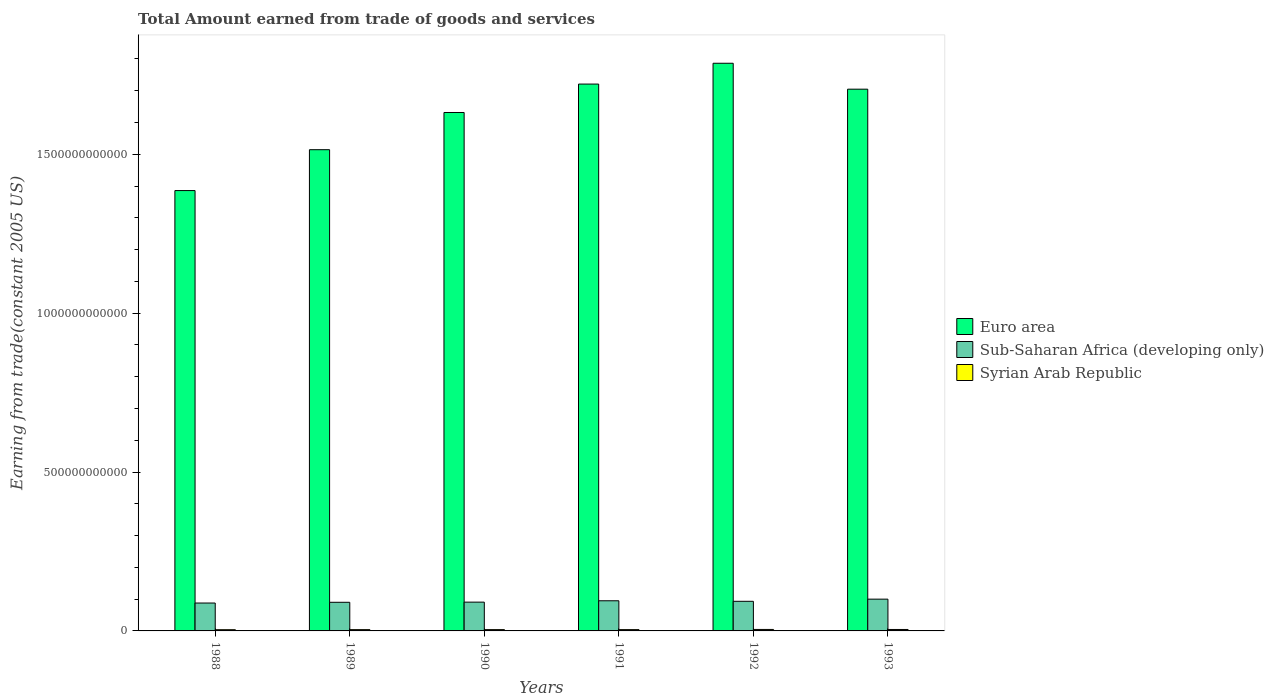How many different coloured bars are there?
Ensure brevity in your answer.  3. How many groups of bars are there?
Make the answer very short. 6. Are the number of bars per tick equal to the number of legend labels?
Make the answer very short. Yes. Are the number of bars on each tick of the X-axis equal?
Offer a terse response. Yes. How many bars are there on the 3rd tick from the left?
Offer a very short reply. 3. What is the label of the 5th group of bars from the left?
Your response must be concise. 1992. What is the total amount earned by trading goods and services in Euro area in 1989?
Make the answer very short. 1.51e+12. Across all years, what is the maximum total amount earned by trading goods and services in Sub-Saharan Africa (developing only)?
Make the answer very short. 1.00e+11. Across all years, what is the minimum total amount earned by trading goods and services in Euro area?
Your answer should be very brief. 1.39e+12. In which year was the total amount earned by trading goods and services in Sub-Saharan Africa (developing only) maximum?
Give a very brief answer. 1993. In which year was the total amount earned by trading goods and services in Syrian Arab Republic minimum?
Make the answer very short. 1988. What is the total total amount earned by trading goods and services in Sub-Saharan Africa (developing only) in the graph?
Your answer should be very brief. 5.57e+11. What is the difference between the total amount earned by trading goods and services in Syrian Arab Republic in 1988 and that in 1992?
Ensure brevity in your answer.  -7.70e+08. What is the difference between the total amount earned by trading goods and services in Syrian Arab Republic in 1988 and the total amount earned by trading goods and services in Euro area in 1990?
Offer a terse response. -1.63e+12. What is the average total amount earned by trading goods and services in Euro area per year?
Your response must be concise. 1.62e+12. In the year 1989, what is the difference between the total amount earned by trading goods and services in Euro area and total amount earned by trading goods and services in Sub-Saharan Africa (developing only)?
Make the answer very short. 1.42e+12. In how many years, is the total amount earned by trading goods and services in Euro area greater than 1000000000000 US$?
Offer a very short reply. 6. What is the ratio of the total amount earned by trading goods and services in Syrian Arab Republic in 1991 to that in 1992?
Offer a terse response. 0.89. Is the total amount earned by trading goods and services in Syrian Arab Republic in 1992 less than that in 1993?
Offer a terse response. No. What is the difference between the highest and the second highest total amount earned by trading goods and services in Sub-Saharan Africa (developing only)?
Your answer should be compact. 5.12e+09. What is the difference between the highest and the lowest total amount earned by trading goods and services in Sub-Saharan Africa (developing only)?
Offer a terse response. 1.22e+1. What does the 1st bar from the left in 1989 represents?
Provide a short and direct response. Euro area. What does the 2nd bar from the right in 1988 represents?
Give a very brief answer. Sub-Saharan Africa (developing only). Are all the bars in the graph horizontal?
Make the answer very short. No. How many years are there in the graph?
Offer a terse response. 6. What is the difference between two consecutive major ticks on the Y-axis?
Provide a succinct answer. 5.00e+11. Does the graph contain grids?
Your answer should be very brief. No. How many legend labels are there?
Provide a short and direct response. 3. How are the legend labels stacked?
Keep it short and to the point. Vertical. What is the title of the graph?
Offer a very short reply. Total Amount earned from trade of goods and services. Does "Cayman Islands" appear as one of the legend labels in the graph?
Give a very brief answer. No. What is the label or title of the Y-axis?
Make the answer very short. Earning from trade(constant 2005 US). What is the Earning from trade(constant 2005 US) of Euro area in 1988?
Provide a short and direct response. 1.39e+12. What is the Earning from trade(constant 2005 US) in Sub-Saharan Africa (developing only) in 1988?
Give a very brief answer. 8.78e+1. What is the Earning from trade(constant 2005 US) in Syrian Arab Republic in 1988?
Provide a succinct answer. 3.87e+09. What is the Earning from trade(constant 2005 US) in Euro area in 1989?
Offer a terse response. 1.51e+12. What is the Earning from trade(constant 2005 US) in Sub-Saharan Africa (developing only) in 1989?
Keep it short and to the point. 9.01e+1. What is the Earning from trade(constant 2005 US) of Syrian Arab Republic in 1989?
Offer a very short reply. 4.07e+09. What is the Earning from trade(constant 2005 US) of Euro area in 1990?
Your response must be concise. 1.63e+12. What is the Earning from trade(constant 2005 US) in Sub-Saharan Africa (developing only) in 1990?
Give a very brief answer. 9.06e+1. What is the Earning from trade(constant 2005 US) in Syrian Arab Republic in 1990?
Provide a short and direct response. 4.11e+09. What is the Earning from trade(constant 2005 US) of Euro area in 1991?
Make the answer very short. 1.72e+12. What is the Earning from trade(constant 2005 US) in Sub-Saharan Africa (developing only) in 1991?
Give a very brief answer. 9.49e+1. What is the Earning from trade(constant 2005 US) of Syrian Arab Republic in 1991?
Offer a terse response. 4.11e+09. What is the Earning from trade(constant 2005 US) in Euro area in 1992?
Provide a short and direct response. 1.79e+12. What is the Earning from trade(constant 2005 US) in Sub-Saharan Africa (developing only) in 1992?
Offer a very short reply. 9.32e+1. What is the Earning from trade(constant 2005 US) of Syrian Arab Republic in 1992?
Ensure brevity in your answer.  4.64e+09. What is the Earning from trade(constant 2005 US) in Euro area in 1993?
Offer a very short reply. 1.70e+12. What is the Earning from trade(constant 2005 US) in Sub-Saharan Africa (developing only) in 1993?
Provide a succinct answer. 1.00e+11. What is the Earning from trade(constant 2005 US) in Syrian Arab Republic in 1993?
Keep it short and to the point. 4.53e+09. Across all years, what is the maximum Earning from trade(constant 2005 US) in Euro area?
Ensure brevity in your answer.  1.79e+12. Across all years, what is the maximum Earning from trade(constant 2005 US) of Sub-Saharan Africa (developing only)?
Provide a succinct answer. 1.00e+11. Across all years, what is the maximum Earning from trade(constant 2005 US) in Syrian Arab Republic?
Ensure brevity in your answer.  4.64e+09. Across all years, what is the minimum Earning from trade(constant 2005 US) of Euro area?
Keep it short and to the point. 1.39e+12. Across all years, what is the minimum Earning from trade(constant 2005 US) in Sub-Saharan Africa (developing only)?
Your answer should be compact. 8.78e+1. Across all years, what is the minimum Earning from trade(constant 2005 US) in Syrian Arab Republic?
Keep it short and to the point. 3.87e+09. What is the total Earning from trade(constant 2005 US) of Euro area in the graph?
Ensure brevity in your answer.  9.74e+12. What is the total Earning from trade(constant 2005 US) in Sub-Saharan Africa (developing only) in the graph?
Keep it short and to the point. 5.57e+11. What is the total Earning from trade(constant 2005 US) of Syrian Arab Republic in the graph?
Your response must be concise. 2.53e+1. What is the difference between the Earning from trade(constant 2005 US) in Euro area in 1988 and that in 1989?
Provide a succinct answer. -1.29e+11. What is the difference between the Earning from trade(constant 2005 US) of Sub-Saharan Africa (developing only) in 1988 and that in 1989?
Make the answer very short. -2.34e+09. What is the difference between the Earning from trade(constant 2005 US) in Syrian Arab Republic in 1988 and that in 1989?
Offer a terse response. -2.02e+08. What is the difference between the Earning from trade(constant 2005 US) in Euro area in 1988 and that in 1990?
Offer a very short reply. -2.46e+11. What is the difference between the Earning from trade(constant 2005 US) of Sub-Saharan Africa (developing only) in 1988 and that in 1990?
Give a very brief answer. -2.82e+09. What is the difference between the Earning from trade(constant 2005 US) in Syrian Arab Republic in 1988 and that in 1990?
Provide a succinct answer. -2.37e+08. What is the difference between the Earning from trade(constant 2005 US) of Euro area in 1988 and that in 1991?
Provide a succinct answer. -3.35e+11. What is the difference between the Earning from trade(constant 2005 US) in Sub-Saharan Africa (developing only) in 1988 and that in 1991?
Provide a short and direct response. -7.10e+09. What is the difference between the Earning from trade(constant 2005 US) in Syrian Arab Republic in 1988 and that in 1991?
Your response must be concise. -2.37e+08. What is the difference between the Earning from trade(constant 2005 US) in Euro area in 1988 and that in 1992?
Your response must be concise. -4.01e+11. What is the difference between the Earning from trade(constant 2005 US) of Sub-Saharan Africa (developing only) in 1988 and that in 1992?
Your answer should be very brief. -5.42e+09. What is the difference between the Earning from trade(constant 2005 US) in Syrian Arab Republic in 1988 and that in 1992?
Ensure brevity in your answer.  -7.70e+08. What is the difference between the Earning from trade(constant 2005 US) of Euro area in 1988 and that in 1993?
Offer a terse response. -3.19e+11. What is the difference between the Earning from trade(constant 2005 US) in Sub-Saharan Africa (developing only) in 1988 and that in 1993?
Provide a short and direct response. -1.22e+1. What is the difference between the Earning from trade(constant 2005 US) of Syrian Arab Republic in 1988 and that in 1993?
Ensure brevity in your answer.  -6.60e+08. What is the difference between the Earning from trade(constant 2005 US) of Euro area in 1989 and that in 1990?
Keep it short and to the point. -1.17e+11. What is the difference between the Earning from trade(constant 2005 US) in Sub-Saharan Africa (developing only) in 1989 and that in 1990?
Offer a very short reply. -4.75e+08. What is the difference between the Earning from trade(constant 2005 US) of Syrian Arab Republic in 1989 and that in 1990?
Your answer should be compact. -3.50e+07. What is the difference between the Earning from trade(constant 2005 US) in Euro area in 1989 and that in 1991?
Your answer should be compact. -2.07e+11. What is the difference between the Earning from trade(constant 2005 US) of Sub-Saharan Africa (developing only) in 1989 and that in 1991?
Offer a terse response. -4.76e+09. What is the difference between the Earning from trade(constant 2005 US) in Syrian Arab Republic in 1989 and that in 1991?
Your answer should be compact. -3.55e+07. What is the difference between the Earning from trade(constant 2005 US) in Euro area in 1989 and that in 1992?
Offer a terse response. -2.72e+11. What is the difference between the Earning from trade(constant 2005 US) in Sub-Saharan Africa (developing only) in 1989 and that in 1992?
Offer a terse response. -3.08e+09. What is the difference between the Earning from trade(constant 2005 US) of Syrian Arab Republic in 1989 and that in 1992?
Make the answer very short. -5.68e+08. What is the difference between the Earning from trade(constant 2005 US) in Euro area in 1989 and that in 1993?
Offer a terse response. -1.90e+11. What is the difference between the Earning from trade(constant 2005 US) in Sub-Saharan Africa (developing only) in 1989 and that in 1993?
Provide a succinct answer. -9.88e+09. What is the difference between the Earning from trade(constant 2005 US) of Syrian Arab Republic in 1989 and that in 1993?
Provide a short and direct response. -4.59e+08. What is the difference between the Earning from trade(constant 2005 US) of Euro area in 1990 and that in 1991?
Your answer should be very brief. -8.94e+1. What is the difference between the Earning from trade(constant 2005 US) of Sub-Saharan Africa (developing only) in 1990 and that in 1991?
Offer a terse response. -4.28e+09. What is the difference between the Earning from trade(constant 2005 US) of Syrian Arab Republic in 1990 and that in 1991?
Provide a short and direct response. -5.72e+05. What is the difference between the Earning from trade(constant 2005 US) of Euro area in 1990 and that in 1992?
Your answer should be very brief. -1.55e+11. What is the difference between the Earning from trade(constant 2005 US) of Sub-Saharan Africa (developing only) in 1990 and that in 1992?
Ensure brevity in your answer.  -2.60e+09. What is the difference between the Earning from trade(constant 2005 US) of Syrian Arab Republic in 1990 and that in 1992?
Your response must be concise. -5.33e+08. What is the difference between the Earning from trade(constant 2005 US) of Euro area in 1990 and that in 1993?
Your answer should be very brief. -7.34e+1. What is the difference between the Earning from trade(constant 2005 US) in Sub-Saharan Africa (developing only) in 1990 and that in 1993?
Keep it short and to the point. -9.40e+09. What is the difference between the Earning from trade(constant 2005 US) in Syrian Arab Republic in 1990 and that in 1993?
Give a very brief answer. -4.24e+08. What is the difference between the Earning from trade(constant 2005 US) of Euro area in 1991 and that in 1992?
Your answer should be very brief. -6.55e+1. What is the difference between the Earning from trade(constant 2005 US) of Sub-Saharan Africa (developing only) in 1991 and that in 1992?
Offer a very short reply. 1.68e+09. What is the difference between the Earning from trade(constant 2005 US) in Syrian Arab Republic in 1991 and that in 1992?
Provide a short and direct response. -5.32e+08. What is the difference between the Earning from trade(constant 2005 US) in Euro area in 1991 and that in 1993?
Your answer should be very brief. 1.61e+1. What is the difference between the Earning from trade(constant 2005 US) in Sub-Saharan Africa (developing only) in 1991 and that in 1993?
Your answer should be very brief. -5.12e+09. What is the difference between the Earning from trade(constant 2005 US) of Syrian Arab Republic in 1991 and that in 1993?
Your response must be concise. -4.23e+08. What is the difference between the Earning from trade(constant 2005 US) in Euro area in 1992 and that in 1993?
Ensure brevity in your answer.  8.16e+1. What is the difference between the Earning from trade(constant 2005 US) in Sub-Saharan Africa (developing only) in 1992 and that in 1993?
Offer a very short reply. -6.80e+09. What is the difference between the Earning from trade(constant 2005 US) in Syrian Arab Republic in 1992 and that in 1993?
Provide a succinct answer. 1.09e+08. What is the difference between the Earning from trade(constant 2005 US) of Euro area in 1988 and the Earning from trade(constant 2005 US) of Sub-Saharan Africa (developing only) in 1989?
Keep it short and to the point. 1.30e+12. What is the difference between the Earning from trade(constant 2005 US) of Euro area in 1988 and the Earning from trade(constant 2005 US) of Syrian Arab Republic in 1989?
Your answer should be very brief. 1.38e+12. What is the difference between the Earning from trade(constant 2005 US) of Sub-Saharan Africa (developing only) in 1988 and the Earning from trade(constant 2005 US) of Syrian Arab Republic in 1989?
Keep it short and to the point. 8.37e+1. What is the difference between the Earning from trade(constant 2005 US) in Euro area in 1988 and the Earning from trade(constant 2005 US) in Sub-Saharan Africa (developing only) in 1990?
Offer a very short reply. 1.30e+12. What is the difference between the Earning from trade(constant 2005 US) in Euro area in 1988 and the Earning from trade(constant 2005 US) in Syrian Arab Republic in 1990?
Give a very brief answer. 1.38e+12. What is the difference between the Earning from trade(constant 2005 US) in Sub-Saharan Africa (developing only) in 1988 and the Earning from trade(constant 2005 US) in Syrian Arab Republic in 1990?
Offer a terse response. 8.37e+1. What is the difference between the Earning from trade(constant 2005 US) of Euro area in 1988 and the Earning from trade(constant 2005 US) of Sub-Saharan Africa (developing only) in 1991?
Your response must be concise. 1.29e+12. What is the difference between the Earning from trade(constant 2005 US) of Euro area in 1988 and the Earning from trade(constant 2005 US) of Syrian Arab Republic in 1991?
Offer a very short reply. 1.38e+12. What is the difference between the Earning from trade(constant 2005 US) of Sub-Saharan Africa (developing only) in 1988 and the Earning from trade(constant 2005 US) of Syrian Arab Republic in 1991?
Your answer should be very brief. 8.37e+1. What is the difference between the Earning from trade(constant 2005 US) in Euro area in 1988 and the Earning from trade(constant 2005 US) in Sub-Saharan Africa (developing only) in 1992?
Ensure brevity in your answer.  1.29e+12. What is the difference between the Earning from trade(constant 2005 US) in Euro area in 1988 and the Earning from trade(constant 2005 US) in Syrian Arab Republic in 1992?
Provide a short and direct response. 1.38e+12. What is the difference between the Earning from trade(constant 2005 US) of Sub-Saharan Africa (developing only) in 1988 and the Earning from trade(constant 2005 US) of Syrian Arab Republic in 1992?
Your response must be concise. 8.32e+1. What is the difference between the Earning from trade(constant 2005 US) in Euro area in 1988 and the Earning from trade(constant 2005 US) in Sub-Saharan Africa (developing only) in 1993?
Your response must be concise. 1.29e+12. What is the difference between the Earning from trade(constant 2005 US) in Euro area in 1988 and the Earning from trade(constant 2005 US) in Syrian Arab Republic in 1993?
Your answer should be very brief. 1.38e+12. What is the difference between the Earning from trade(constant 2005 US) in Sub-Saharan Africa (developing only) in 1988 and the Earning from trade(constant 2005 US) in Syrian Arab Republic in 1993?
Offer a terse response. 8.33e+1. What is the difference between the Earning from trade(constant 2005 US) in Euro area in 1989 and the Earning from trade(constant 2005 US) in Sub-Saharan Africa (developing only) in 1990?
Ensure brevity in your answer.  1.42e+12. What is the difference between the Earning from trade(constant 2005 US) in Euro area in 1989 and the Earning from trade(constant 2005 US) in Syrian Arab Republic in 1990?
Offer a very short reply. 1.51e+12. What is the difference between the Earning from trade(constant 2005 US) of Sub-Saharan Africa (developing only) in 1989 and the Earning from trade(constant 2005 US) of Syrian Arab Republic in 1990?
Your response must be concise. 8.60e+1. What is the difference between the Earning from trade(constant 2005 US) of Euro area in 1989 and the Earning from trade(constant 2005 US) of Sub-Saharan Africa (developing only) in 1991?
Your answer should be compact. 1.42e+12. What is the difference between the Earning from trade(constant 2005 US) in Euro area in 1989 and the Earning from trade(constant 2005 US) in Syrian Arab Republic in 1991?
Your answer should be compact. 1.51e+12. What is the difference between the Earning from trade(constant 2005 US) of Sub-Saharan Africa (developing only) in 1989 and the Earning from trade(constant 2005 US) of Syrian Arab Republic in 1991?
Provide a succinct answer. 8.60e+1. What is the difference between the Earning from trade(constant 2005 US) in Euro area in 1989 and the Earning from trade(constant 2005 US) in Sub-Saharan Africa (developing only) in 1992?
Provide a short and direct response. 1.42e+12. What is the difference between the Earning from trade(constant 2005 US) in Euro area in 1989 and the Earning from trade(constant 2005 US) in Syrian Arab Republic in 1992?
Make the answer very short. 1.51e+12. What is the difference between the Earning from trade(constant 2005 US) in Sub-Saharan Africa (developing only) in 1989 and the Earning from trade(constant 2005 US) in Syrian Arab Republic in 1992?
Your answer should be compact. 8.55e+1. What is the difference between the Earning from trade(constant 2005 US) in Euro area in 1989 and the Earning from trade(constant 2005 US) in Sub-Saharan Africa (developing only) in 1993?
Provide a short and direct response. 1.41e+12. What is the difference between the Earning from trade(constant 2005 US) in Euro area in 1989 and the Earning from trade(constant 2005 US) in Syrian Arab Republic in 1993?
Offer a terse response. 1.51e+12. What is the difference between the Earning from trade(constant 2005 US) in Sub-Saharan Africa (developing only) in 1989 and the Earning from trade(constant 2005 US) in Syrian Arab Republic in 1993?
Give a very brief answer. 8.56e+1. What is the difference between the Earning from trade(constant 2005 US) of Euro area in 1990 and the Earning from trade(constant 2005 US) of Sub-Saharan Africa (developing only) in 1991?
Keep it short and to the point. 1.54e+12. What is the difference between the Earning from trade(constant 2005 US) of Euro area in 1990 and the Earning from trade(constant 2005 US) of Syrian Arab Republic in 1991?
Offer a terse response. 1.63e+12. What is the difference between the Earning from trade(constant 2005 US) of Sub-Saharan Africa (developing only) in 1990 and the Earning from trade(constant 2005 US) of Syrian Arab Republic in 1991?
Keep it short and to the point. 8.65e+1. What is the difference between the Earning from trade(constant 2005 US) in Euro area in 1990 and the Earning from trade(constant 2005 US) in Sub-Saharan Africa (developing only) in 1992?
Provide a short and direct response. 1.54e+12. What is the difference between the Earning from trade(constant 2005 US) in Euro area in 1990 and the Earning from trade(constant 2005 US) in Syrian Arab Republic in 1992?
Make the answer very short. 1.63e+12. What is the difference between the Earning from trade(constant 2005 US) in Sub-Saharan Africa (developing only) in 1990 and the Earning from trade(constant 2005 US) in Syrian Arab Republic in 1992?
Ensure brevity in your answer.  8.60e+1. What is the difference between the Earning from trade(constant 2005 US) in Euro area in 1990 and the Earning from trade(constant 2005 US) in Sub-Saharan Africa (developing only) in 1993?
Provide a short and direct response. 1.53e+12. What is the difference between the Earning from trade(constant 2005 US) in Euro area in 1990 and the Earning from trade(constant 2005 US) in Syrian Arab Republic in 1993?
Give a very brief answer. 1.63e+12. What is the difference between the Earning from trade(constant 2005 US) in Sub-Saharan Africa (developing only) in 1990 and the Earning from trade(constant 2005 US) in Syrian Arab Republic in 1993?
Give a very brief answer. 8.61e+1. What is the difference between the Earning from trade(constant 2005 US) in Euro area in 1991 and the Earning from trade(constant 2005 US) in Sub-Saharan Africa (developing only) in 1992?
Ensure brevity in your answer.  1.63e+12. What is the difference between the Earning from trade(constant 2005 US) in Euro area in 1991 and the Earning from trade(constant 2005 US) in Syrian Arab Republic in 1992?
Keep it short and to the point. 1.72e+12. What is the difference between the Earning from trade(constant 2005 US) of Sub-Saharan Africa (developing only) in 1991 and the Earning from trade(constant 2005 US) of Syrian Arab Republic in 1992?
Provide a short and direct response. 9.03e+1. What is the difference between the Earning from trade(constant 2005 US) in Euro area in 1991 and the Earning from trade(constant 2005 US) in Sub-Saharan Africa (developing only) in 1993?
Provide a succinct answer. 1.62e+12. What is the difference between the Earning from trade(constant 2005 US) in Euro area in 1991 and the Earning from trade(constant 2005 US) in Syrian Arab Republic in 1993?
Make the answer very short. 1.72e+12. What is the difference between the Earning from trade(constant 2005 US) in Sub-Saharan Africa (developing only) in 1991 and the Earning from trade(constant 2005 US) in Syrian Arab Republic in 1993?
Your answer should be compact. 9.04e+1. What is the difference between the Earning from trade(constant 2005 US) of Euro area in 1992 and the Earning from trade(constant 2005 US) of Sub-Saharan Africa (developing only) in 1993?
Keep it short and to the point. 1.69e+12. What is the difference between the Earning from trade(constant 2005 US) of Euro area in 1992 and the Earning from trade(constant 2005 US) of Syrian Arab Republic in 1993?
Provide a succinct answer. 1.78e+12. What is the difference between the Earning from trade(constant 2005 US) of Sub-Saharan Africa (developing only) in 1992 and the Earning from trade(constant 2005 US) of Syrian Arab Republic in 1993?
Offer a terse response. 8.87e+1. What is the average Earning from trade(constant 2005 US) in Euro area per year?
Provide a short and direct response. 1.62e+12. What is the average Earning from trade(constant 2005 US) in Sub-Saharan Africa (developing only) per year?
Keep it short and to the point. 9.28e+1. What is the average Earning from trade(constant 2005 US) in Syrian Arab Republic per year?
Make the answer very short. 4.22e+09. In the year 1988, what is the difference between the Earning from trade(constant 2005 US) of Euro area and Earning from trade(constant 2005 US) of Sub-Saharan Africa (developing only)?
Provide a succinct answer. 1.30e+12. In the year 1988, what is the difference between the Earning from trade(constant 2005 US) in Euro area and Earning from trade(constant 2005 US) in Syrian Arab Republic?
Your answer should be compact. 1.38e+12. In the year 1988, what is the difference between the Earning from trade(constant 2005 US) in Sub-Saharan Africa (developing only) and Earning from trade(constant 2005 US) in Syrian Arab Republic?
Offer a terse response. 8.39e+1. In the year 1989, what is the difference between the Earning from trade(constant 2005 US) in Euro area and Earning from trade(constant 2005 US) in Sub-Saharan Africa (developing only)?
Offer a very short reply. 1.42e+12. In the year 1989, what is the difference between the Earning from trade(constant 2005 US) in Euro area and Earning from trade(constant 2005 US) in Syrian Arab Republic?
Provide a succinct answer. 1.51e+12. In the year 1989, what is the difference between the Earning from trade(constant 2005 US) in Sub-Saharan Africa (developing only) and Earning from trade(constant 2005 US) in Syrian Arab Republic?
Ensure brevity in your answer.  8.61e+1. In the year 1990, what is the difference between the Earning from trade(constant 2005 US) in Euro area and Earning from trade(constant 2005 US) in Sub-Saharan Africa (developing only)?
Give a very brief answer. 1.54e+12. In the year 1990, what is the difference between the Earning from trade(constant 2005 US) in Euro area and Earning from trade(constant 2005 US) in Syrian Arab Republic?
Your answer should be compact. 1.63e+12. In the year 1990, what is the difference between the Earning from trade(constant 2005 US) in Sub-Saharan Africa (developing only) and Earning from trade(constant 2005 US) in Syrian Arab Republic?
Your answer should be very brief. 8.65e+1. In the year 1991, what is the difference between the Earning from trade(constant 2005 US) in Euro area and Earning from trade(constant 2005 US) in Sub-Saharan Africa (developing only)?
Your response must be concise. 1.63e+12. In the year 1991, what is the difference between the Earning from trade(constant 2005 US) in Euro area and Earning from trade(constant 2005 US) in Syrian Arab Republic?
Offer a terse response. 1.72e+12. In the year 1991, what is the difference between the Earning from trade(constant 2005 US) in Sub-Saharan Africa (developing only) and Earning from trade(constant 2005 US) in Syrian Arab Republic?
Ensure brevity in your answer.  9.08e+1. In the year 1992, what is the difference between the Earning from trade(constant 2005 US) of Euro area and Earning from trade(constant 2005 US) of Sub-Saharan Africa (developing only)?
Provide a succinct answer. 1.69e+12. In the year 1992, what is the difference between the Earning from trade(constant 2005 US) in Euro area and Earning from trade(constant 2005 US) in Syrian Arab Republic?
Your response must be concise. 1.78e+12. In the year 1992, what is the difference between the Earning from trade(constant 2005 US) in Sub-Saharan Africa (developing only) and Earning from trade(constant 2005 US) in Syrian Arab Republic?
Your answer should be very brief. 8.86e+1. In the year 1993, what is the difference between the Earning from trade(constant 2005 US) in Euro area and Earning from trade(constant 2005 US) in Sub-Saharan Africa (developing only)?
Keep it short and to the point. 1.60e+12. In the year 1993, what is the difference between the Earning from trade(constant 2005 US) in Euro area and Earning from trade(constant 2005 US) in Syrian Arab Republic?
Ensure brevity in your answer.  1.70e+12. In the year 1993, what is the difference between the Earning from trade(constant 2005 US) of Sub-Saharan Africa (developing only) and Earning from trade(constant 2005 US) of Syrian Arab Republic?
Provide a short and direct response. 9.55e+1. What is the ratio of the Earning from trade(constant 2005 US) in Euro area in 1988 to that in 1989?
Your answer should be compact. 0.92. What is the ratio of the Earning from trade(constant 2005 US) of Syrian Arab Republic in 1988 to that in 1989?
Provide a short and direct response. 0.95. What is the ratio of the Earning from trade(constant 2005 US) of Euro area in 1988 to that in 1990?
Give a very brief answer. 0.85. What is the ratio of the Earning from trade(constant 2005 US) in Sub-Saharan Africa (developing only) in 1988 to that in 1990?
Provide a short and direct response. 0.97. What is the ratio of the Earning from trade(constant 2005 US) of Syrian Arab Republic in 1988 to that in 1990?
Your answer should be very brief. 0.94. What is the ratio of the Earning from trade(constant 2005 US) in Euro area in 1988 to that in 1991?
Your answer should be very brief. 0.81. What is the ratio of the Earning from trade(constant 2005 US) in Sub-Saharan Africa (developing only) in 1988 to that in 1991?
Your answer should be very brief. 0.93. What is the ratio of the Earning from trade(constant 2005 US) in Syrian Arab Republic in 1988 to that in 1991?
Ensure brevity in your answer.  0.94. What is the ratio of the Earning from trade(constant 2005 US) of Euro area in 1988 to that in 1992?
Your response must be concise. 0.78. What is the ratio of the Earning from trade(constant 2005 US) of Sub-Saharan Africa (developing only) in 1988 to that in 1992?
Give a very brief answer. 0.94. What is the ratio of the Earning from trade(constant 2005 US) of Syrian Arab Republic in 1988 to that in 1992?
Your answer should be compact. 0.83. What is the ratio of the Earning from trade(constant 2005 US) in Euro area in 1988 to that in 1993?
Give a very brief answer. 0.81. What is the ratio of the Earning from trade(constant 2005 US) of Sub-Saharan Africa (developing only) in 1988 to that in 1993?
Make the answer very short. 0.88. What is the ratio of the Earning from trade(constant 2005 US) of Syrian Arab Republic in 1988 to that in 1993?
Give a very brief answer. 0.85. What is the ratio of the Earning from trade(constant 2005 US) in Euro area in 1989 to that in 1990?
Provide a succinct answer. 0.93. What is the ratio of the Earning from trade(constant 2005 US) of Euro area in 1989 to that in 1991?
Your answer should be compact. 0.88. What is the ratio of the Earning from trade(constant 2005 US) in Sub-Saharan Africa (developing only) in 1989 to that in 1991?
Offer a very short reply. 0.95. What is the ratio of the Earning from trade(constant 2005 US) in Syrian Arab Republic in 1989 to that in 1991?
Offer a terse response. 0.99. What is the ratio of the Earning from trade(constant 2005 US) in Euro area in 1989 to that in 1992?
Provide a succinct answer. 0.85. What is the ratio of the Earning from trade(constant 2005 US) of Syrian Arab Republic in 1989 to that in 1992?
Keep it short and to the point. 0.88. What is the ratio of the Earning from trade(constant 2005 US) in Euro area in 1989 to that in 1993?
Keep it short and to the point. 0.89. What is the ratio of the Earning from trade(constant 2005 US) in Sub-Saharan Africa (developing only) in 1989 to that in 1993?
Keep it short and to the point. 0.9. What is the ratio of the Earning from trade(constant 2005 US) in Syrian Arab Republic in 1989 to that in 1993?
Keep it short and to the point. 0.9. What is the ratio of the Earning from trade(constant 2005 US) in Euro area in 1990 to that in 1991?
Make the answer very short. 0.95. What is the ratio of the Earning from trade(constant 2005 US) of Sub-Saharan Africa (developing only) in 1990 to that in 1991?
Your answer should be compact. 0.95. What is the ratio of the Earning from trade(constant 2005 US) in Syrian Arab Republic in 1990 to that in 1991?
Offer a very short reply. 1. What is the ratio of the Earning from trade(constant 2005 US) in Euro area in 1990 to that in 1992?
Offer a terse response. 0.91. What is the ratio of the Earning from trade(constant 2005 US) in Sub-Saharan Africa (developing only) in 1990 to that in 1992?
Make the answer very short. 0.97. What is the ratio of the Earning from trade(constant 2005 US) of Syrian Arab Republic in 1990 to that in 1992?
Provide a short and direct response. 0.89. What is the ratio of the Earning from trade(constant 2005 US) in Euro area in 1990 to that in 1993?
Offer a terse response. 0.96. What is the ratio of the Earning from trade(constant 2005 US) in Sub-Saharan Africa (developing only) in 1990 to that in 1993?
Offer a very short reply. 0.91. What is the ratio of the Earning from trade(constant 2005 US) in Syrian Arab Republic in 1990 to that in 1993?
Make the answer very short. 0.91. What is the ratio of the Earning from trade(constant 2005 US) in Euro area in 1991 to that in 1992?
Ensure brevity in your answer.  0.96. What is the ratio of the Earning from trade(constant 2005 US) of Sub-Saharan Africa (developing only) in 1991 to that in 1992?
Provide a short and direct response. 1.02. What is the ratio of the Earning from trade(constant 2005 US) of Syrian Arab Republic in 1991 to that in 1992?
Your answer should be compact. 0.89. What is the ratio of the Earning from trade(constant 2005 US) of Euro area in 1991 to that in 1993?
Your response must be concise. 1.01. What is the ratio of the Earning from trade(constant 2005 US) of Sub-Saharan Africa (developing only) in 1991 to that in 1993?
Give a very brief answer. 0.95. What is the ratio of the Earning from trade(constant 2005 US) in Syrian Arab Republic in 1991 to that in 1993?
Provide a succinct answer. 0.91. What is the ratio of the Earning from trade(constant 2005 US) of Euro area in 1992 to that in 1993?
Your answer should be very brief. 1.05. What is the ratio of the Earning from trade(constant 2005 US) in Sub-Saharan Africa (developing only) in 1992 to that in 1993?
Give a very brief answer. 0.93. What is the ratio of the Earning from trade(constant 2005 US) of Syrian Arab Republic in 1992 to that in 1993?
Offer a terse response. 1.02. What is the difference between the highest and the second highest Earning from trade(constant 2005 US) in Euro area?
Provide a short and direct response. 6.55e+1. What is the difference between the highest and the second highest Earning from trade(constant 2005 US) in Sub-Saharan Africa (developing only)?
Your answer should be very brief. 5.12e+09. What is the difference between the highest and the second highest Earning from trade(constant 2005 US) in Syrian Arab Republic?
Give a very brief answer. 1.09e+08. What is the difference between the highest and the lowest Earning from trade(constant 2005 US) of Euro area?
Provide a succinct answer. 4.01e+11. What is the difference between the highest and the lowest Earning from trade(constant 2005 US) of Sub-Saharan Africa (developing only)?
Offer a very short reply. 1.22e+1. What is the difference between the highest and the lowest Earning from trade(constant 2005 US) of Syrian Arab Republic?
Make the answer very short. 7.70e+08. 